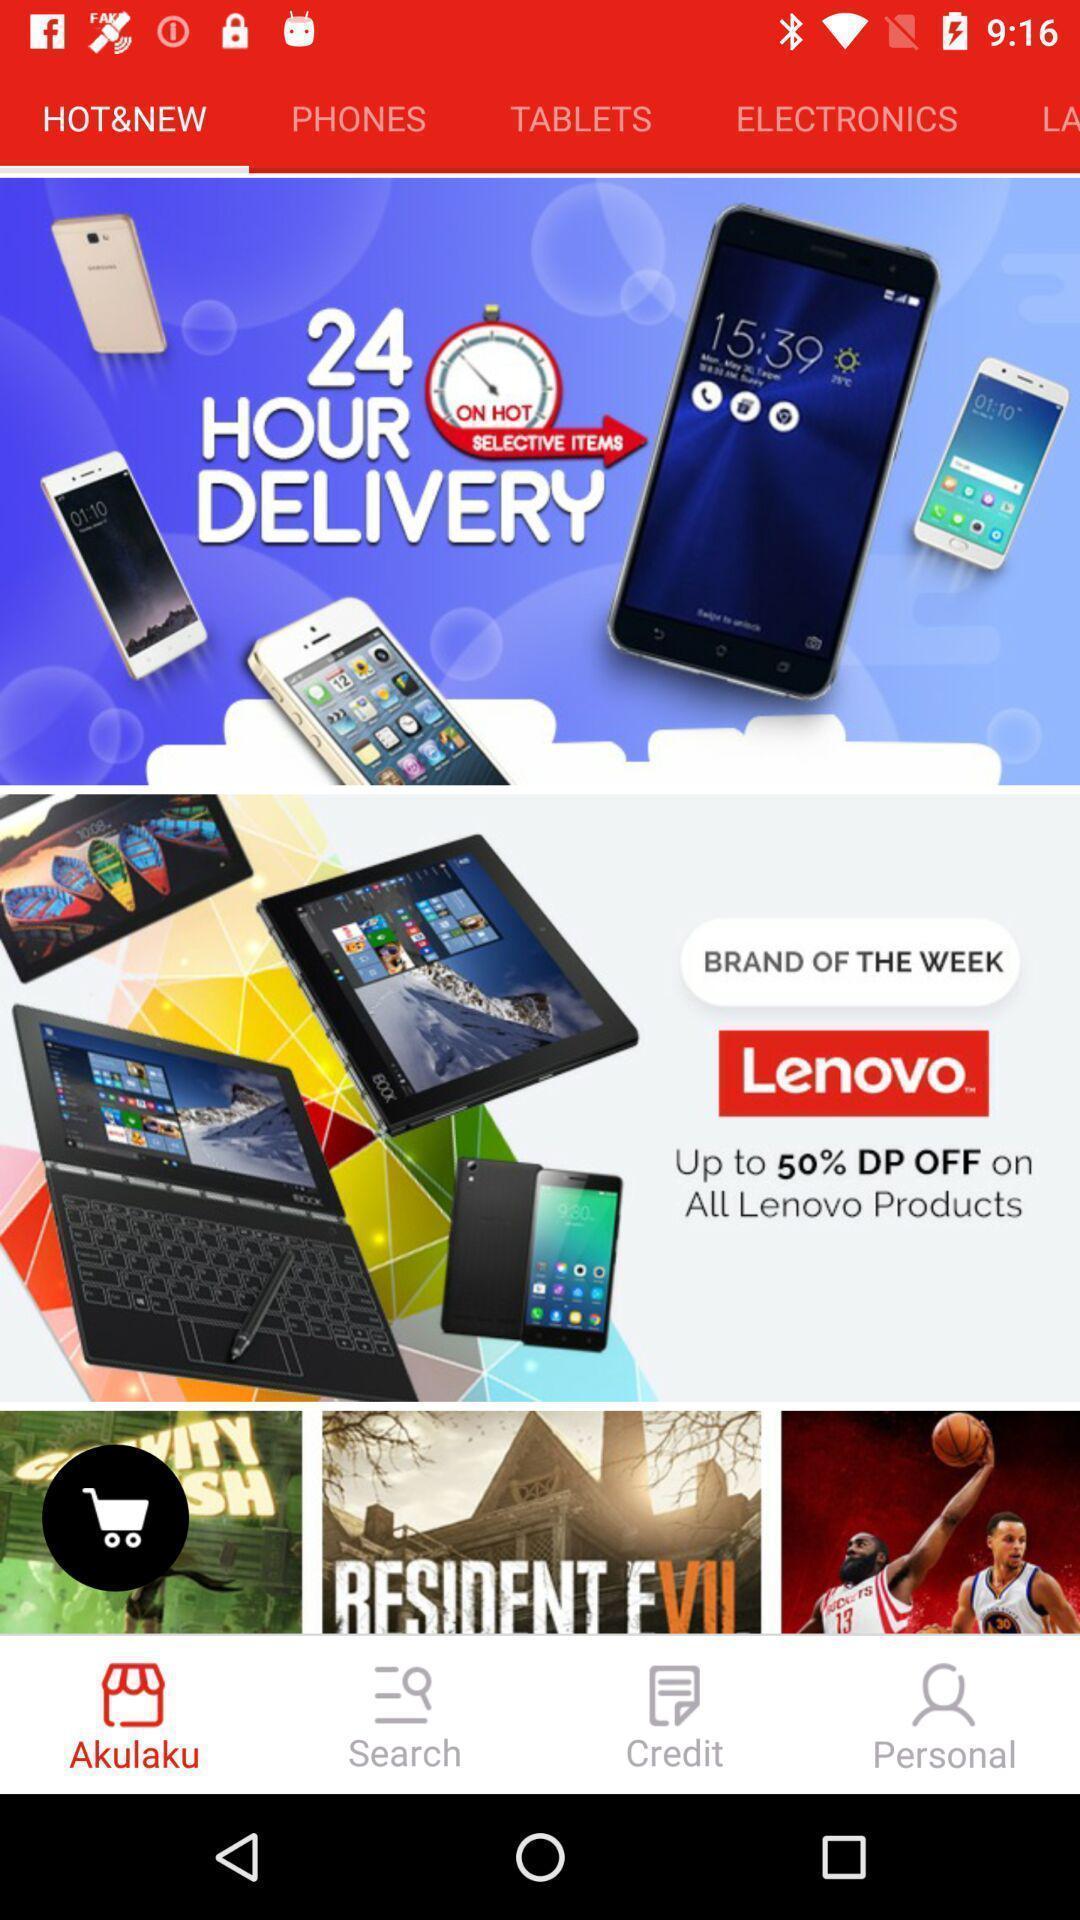Provide a description of this screenshot. Screen showing various new electronics of an shopping app. 